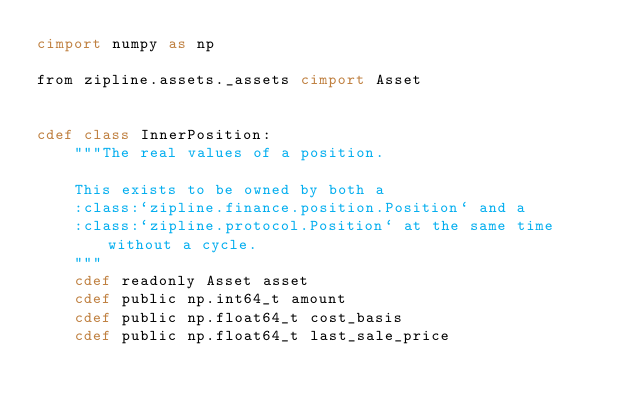<code> <loc_0><loc_0><loc_500><loc_500><_Cython_>cimport numpy as np

from zipline.assets._assets cimport Asset


cdef class InnerPosition:
    """The real values of a position.

    This exists to be owned by both a
    :class:`zipline.finance.position.Position` and a
    :class:`zipline.protocol.Position` at the same time without a cycle.
    """
    cdef readonly Asset asset
    cdef public np.int64_t amount
    cdef public np.float64_t cost_basis
    cdef public np.float64_t last_sale_price</code> 